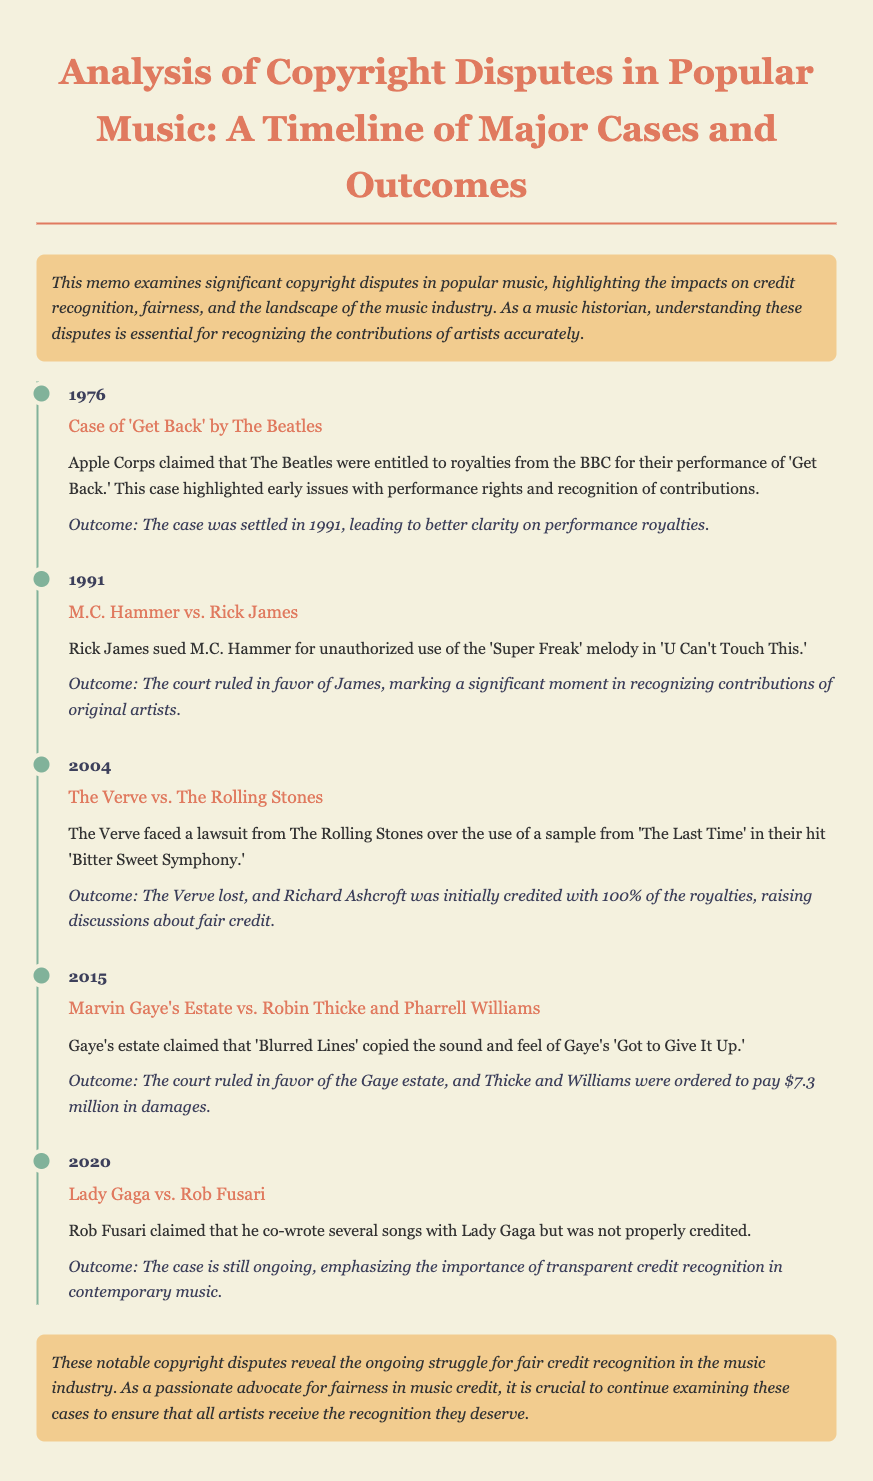What year did the case of 'Get Back' occur? The year mentioned in the document for the 'Get Back' case is 1976.
Answer: 1976 Who sued M.C. Hammer for unauthorized use? The case states that Rick James sued M.C. Hammer.
Answer: Rick James What was the outcome for The Verve in their lawsuit? The document indicates that The Verve lost the lawsuit against The Rolling Stones.
Answer: Lost How much were Thicke and Williams ordered to pay in damages? The document specifies that they were ordered to pay $7.3 million.
Answer: $7.3 million What ongoing case emphasizes transparent credit recognition? The case mentioned that is still ongoing involves Lady Gaga and Rob Fusari.
Answer: Lady Gaga vs. Rob Fusari What is a common theme among the cases discussed? The memo highlights the common theme of fair credit recognition in the music industry.
Answer: Fair credit recognition What was the significant outcome of the 1991 case? The outcome of the M.C. Hammer vs. Rick James case marked a significant moment in recognizing contributions of original artists.
Answer: Recognition of contributions Which artist's estate claimed a copyright violation in 2015? The estate of Marvin Gaye claimed the violation against Thicke and Williams.
Answer: Marvin Gaye's Estate 